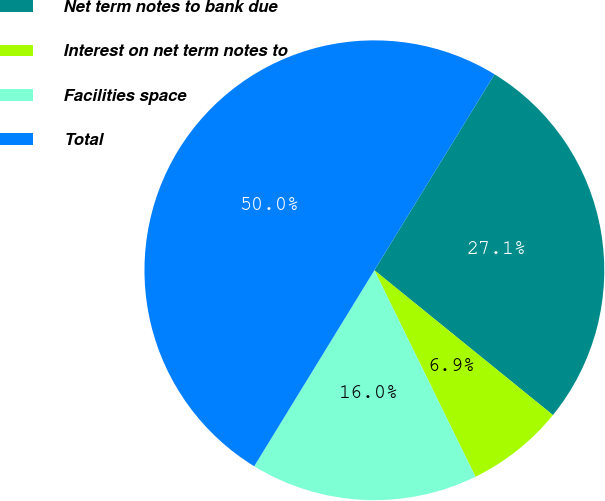<chart> <loc_0><loc_0><loc_500><loc_500><pie_chart><fcel>Net term notes to bank due<fcel>Interest on net term notes to<fcel>Facilities space<fcel>Total<nl><fcel>27.09%<fcel>6.91%<fcel>16.0%<fcel>50.0%<nl></chart> 